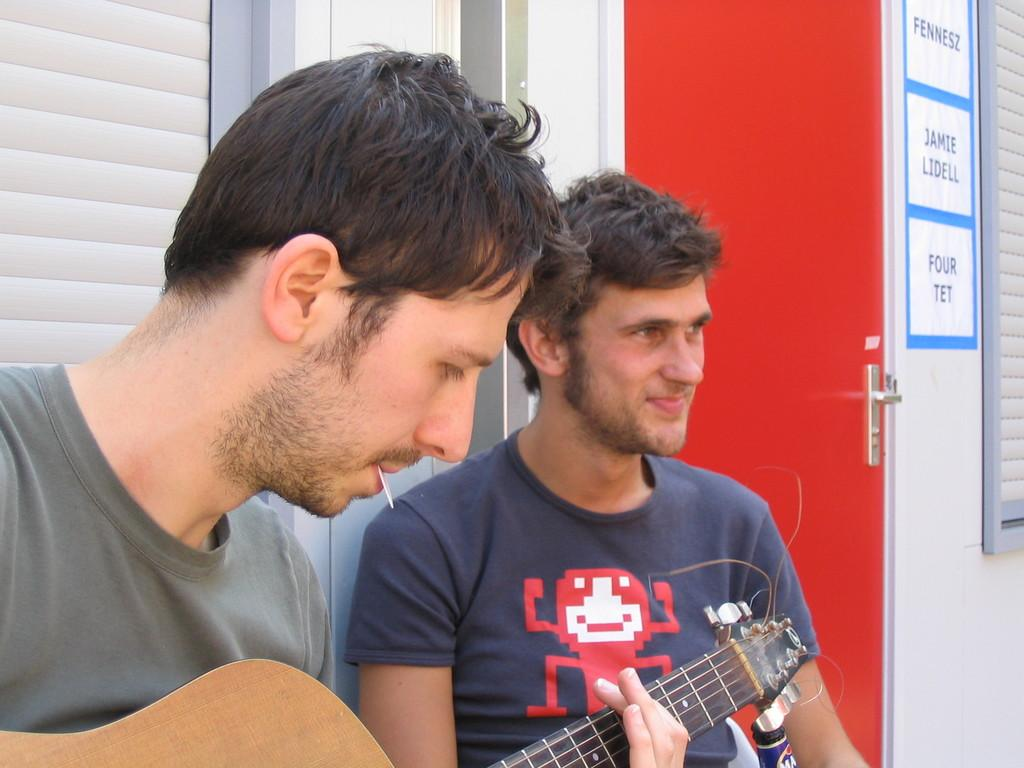What is on the wall in the image? There is a poster on a wall in the image. What architectural feature can be seen in the image? There is a door in the image. What is happening in the picture within the image? There are two men in a picture, and one of them is playing a guitar. What type of throat condition does the man playing the guitar have in the image? There is no indication of any throat condition in the image; the man is simply playing a guitar. Can you see a toad in the image? There is no toad present in the image. 